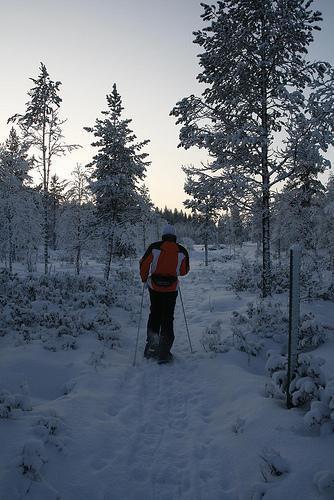How many people are there?
Give a very brief answer. 1. 